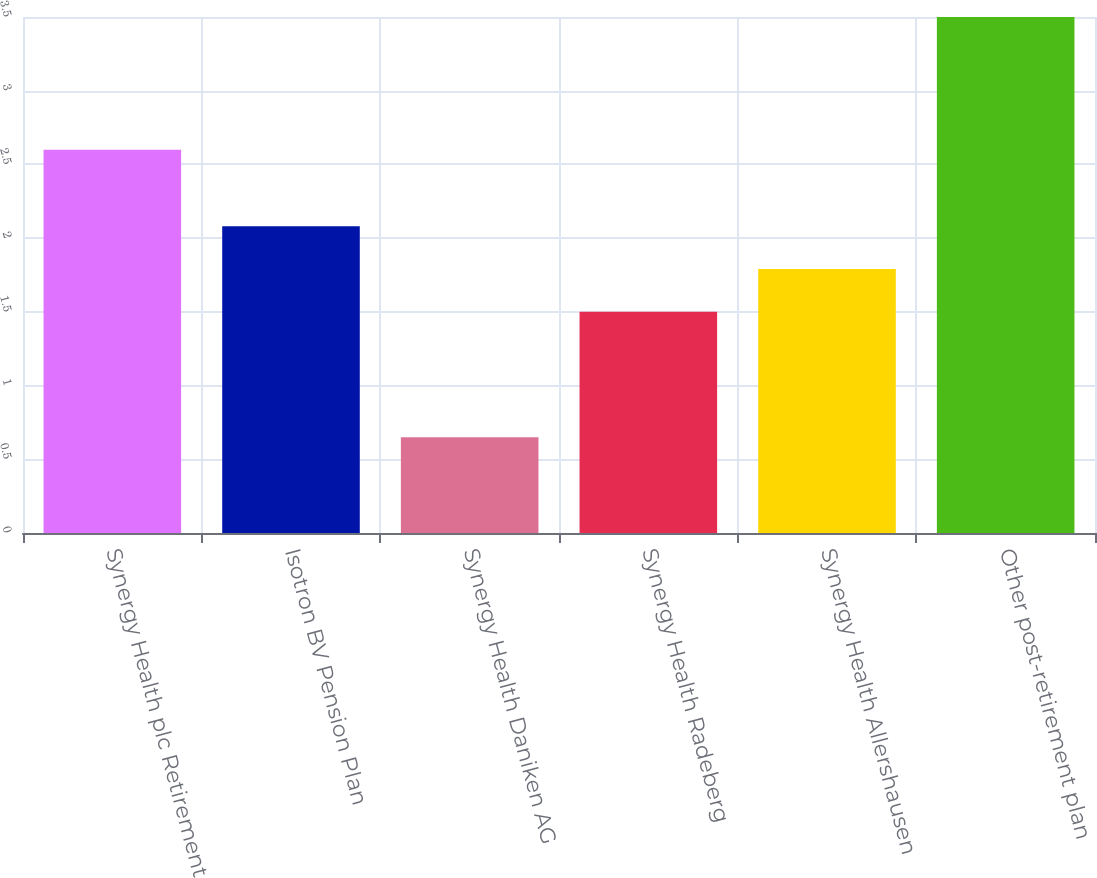Convert chart. <chart><loc_0><loc_0><loc_500><loc_500><bar_chart><fcel>Synergy Health plc Retirement<fcel>Isotron BV Pension Plan<fcel>Synergy Health Daniken AG<fcel>Synergy Health Radeberg<fcel>Synergy Health Allershausen<fcel>Other post-retirement plan<nl><fcel>2.6<fcel>2.08<fcel>0.65<fcel>1.5<fcel>1.79<fcel>3.5<nl></chart> 